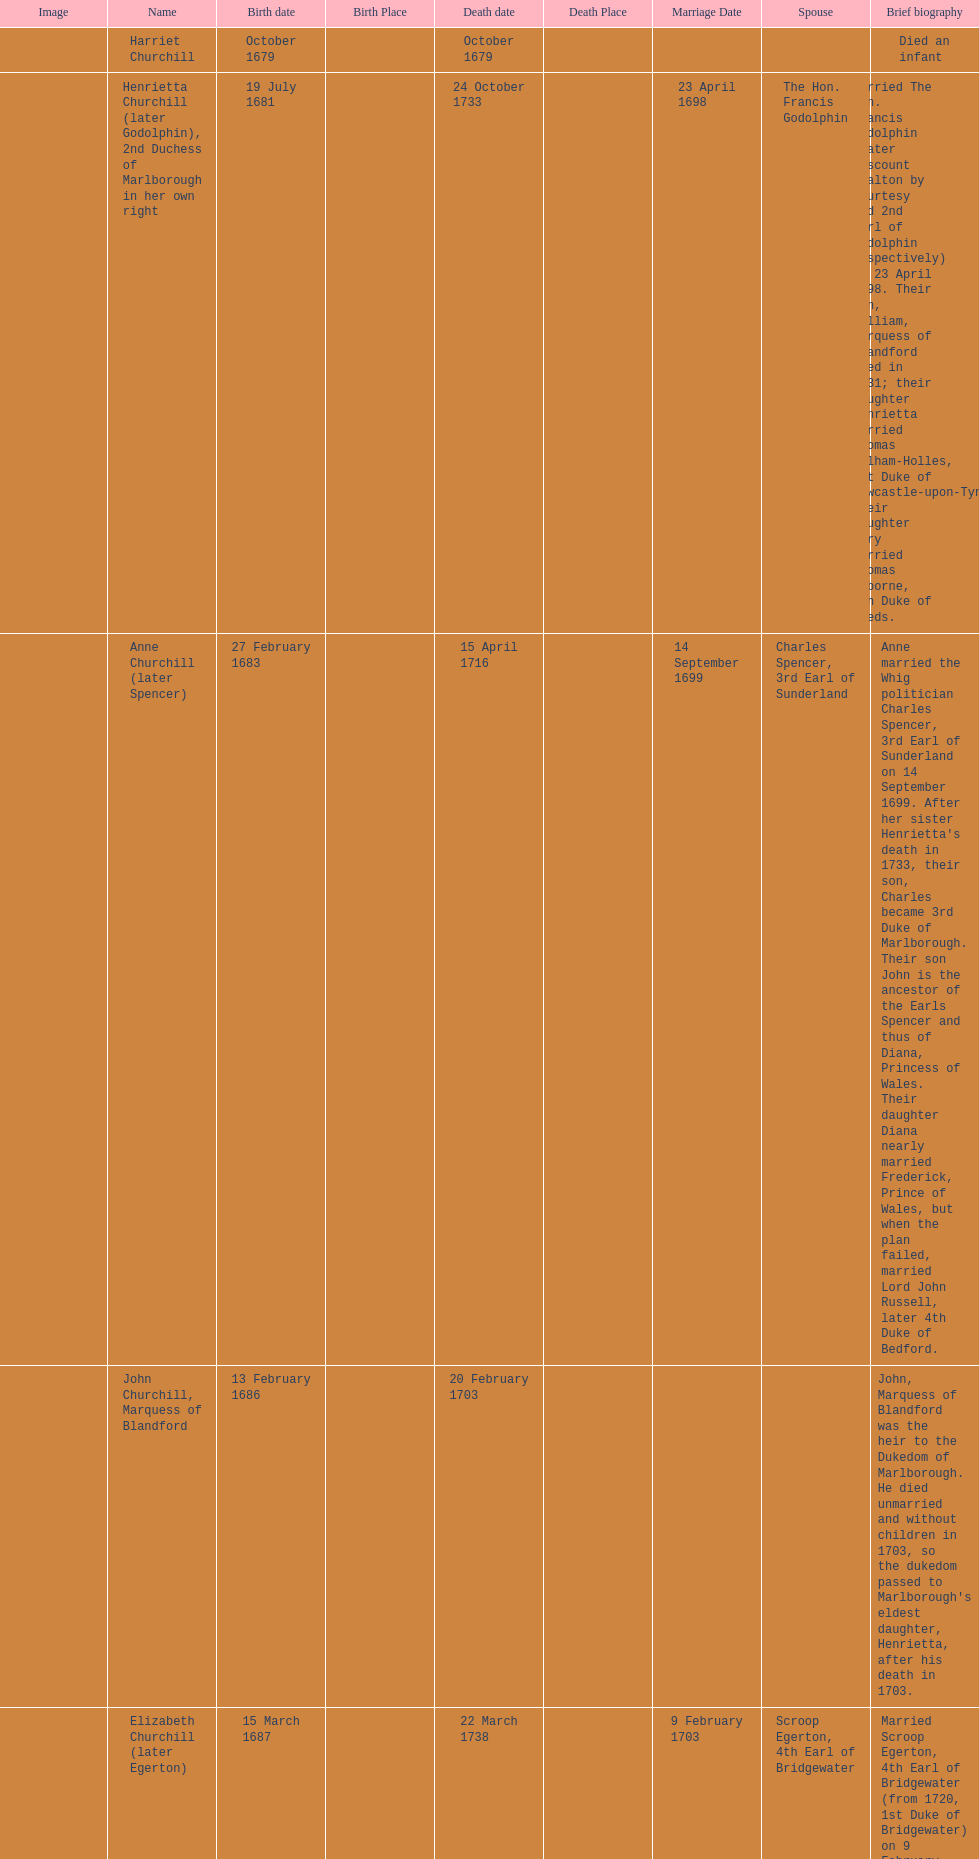How many children were born in february? 2. 